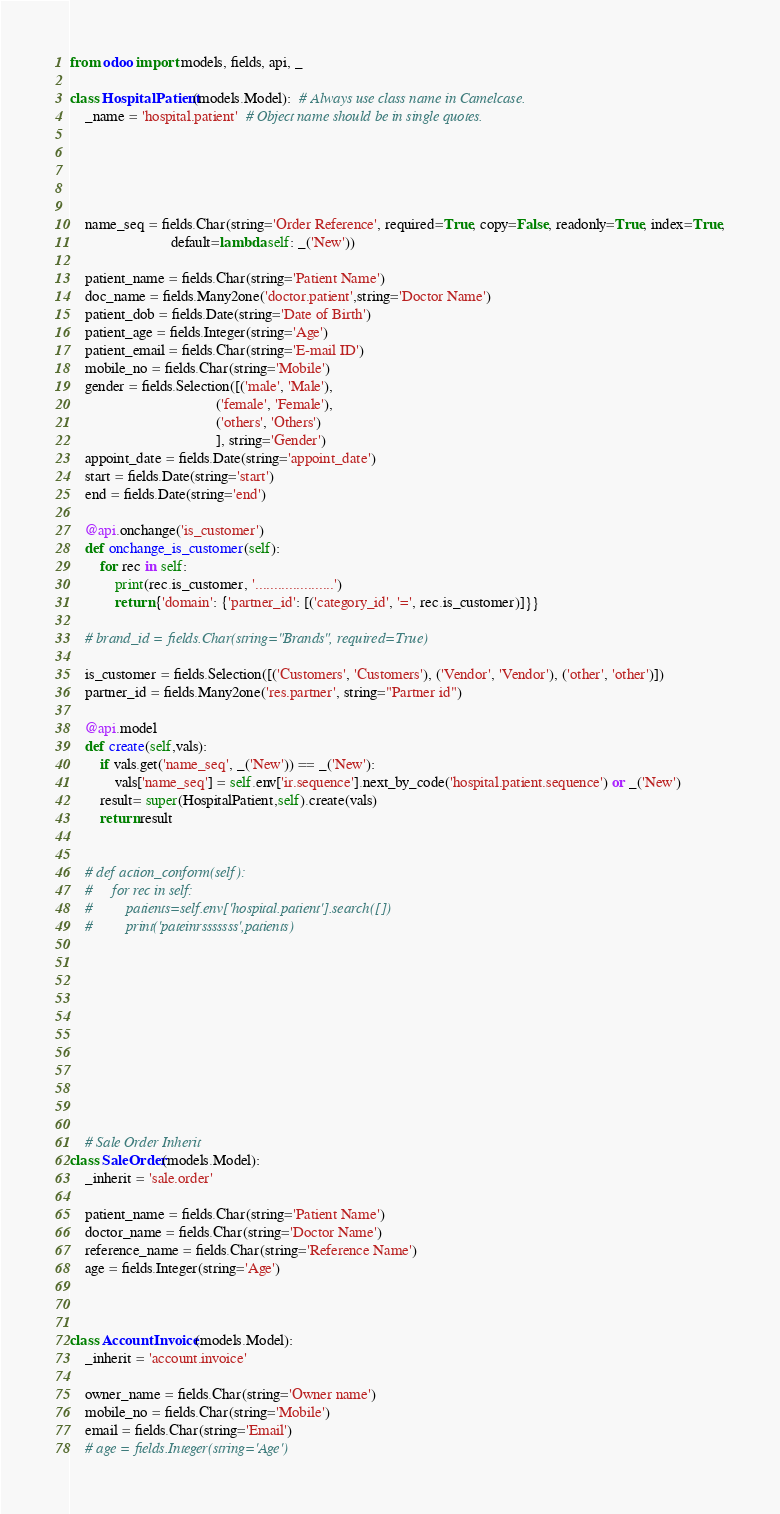Convert code to text. <code><loc_0><loc_0><loc_500><loc_500><_Python_>from odoo import models, fields, api, _

class HospitalPatient(models.Model):  # Always use class name in Camelcase.
    _name = 'hospital.patient'  # Object name should be in single quotes.





    name_seq = fields.Char(string='Order Reference', required=True, copy=False, readonly=True, index=True,
                           default=lambda self: _('New'))

    patient_name = fields.Char(string='Patient Name')
    doc_name = fields.Many2one('doctor.patient',string='Doctor Name')
    patient_dob = fields.Date(string='Date of Birth')
    patient_age = fields.Integer(string='Age')
    patient_email = fields.Char(string='E-mail ID')
    mobile_no = fields.Char(string='Mobile')
    gender = fields.Selection([('male', 'Male'),
                                       ('female', 'Female'),
                                       ('others', 'Others')
                                       ], string='Gender')
    appoint_date = fields.Date(string='appoint_date')
    start = fields.Date(string='start')
    end = fields.Date(string='end')

    @api.onchange('is_customer')
    def onchange_is_customer(self):
        for rec in self:
            print(rec.is_customer, '.....................')
            return {'domain': {'partner_id': [('category_id', '=', rec.is_customer)]}}

    # brand_id = fields.Char(string="Brands", required=True)

    is_customer = fields.Selection([('Customers', 'Customers'), ('Vendor', 'Vendor'), ('other', 'other')])
    partner_id = fields.Many2one('res.partner', string="Partner id")

    @api.model
    def create(self,vals):
        if vals.get('name_seq', _('New')) == _('New'):
            vals['name_seq'] = self.env['ir.sequence'].next_by_code('hospital.patient.sequence') or _('New')
        result= super(HospitalPatient,self).create(vals)
        return result


    # def action_conform(self):
    #     for rec in self:
    #         patients=self.env['hospital.patient'].search([])
    #         print('pateinrsssssss',patients)











    # Sale Order Inherit
class SaleOrder(models.Model):
    _inherit = 'sale.order'

    patient_name = fields.Char(string='Patient Name')
    doctor_name = fields.Char(string='Doctor Name')
    reference_name = fields.Char(string='Reference Name')
    age = fields.Integer(string='Age')



class AccountInvoice(models.Model):
    _inherit = 'account.invoice'

    owner_name = fields.Char(string='Owner name')
    mobile_no = fields.Char(string='Mobile')
    email = fields.Char(string='Email')
    # age = fields.Integer(string='Age')





</code> 